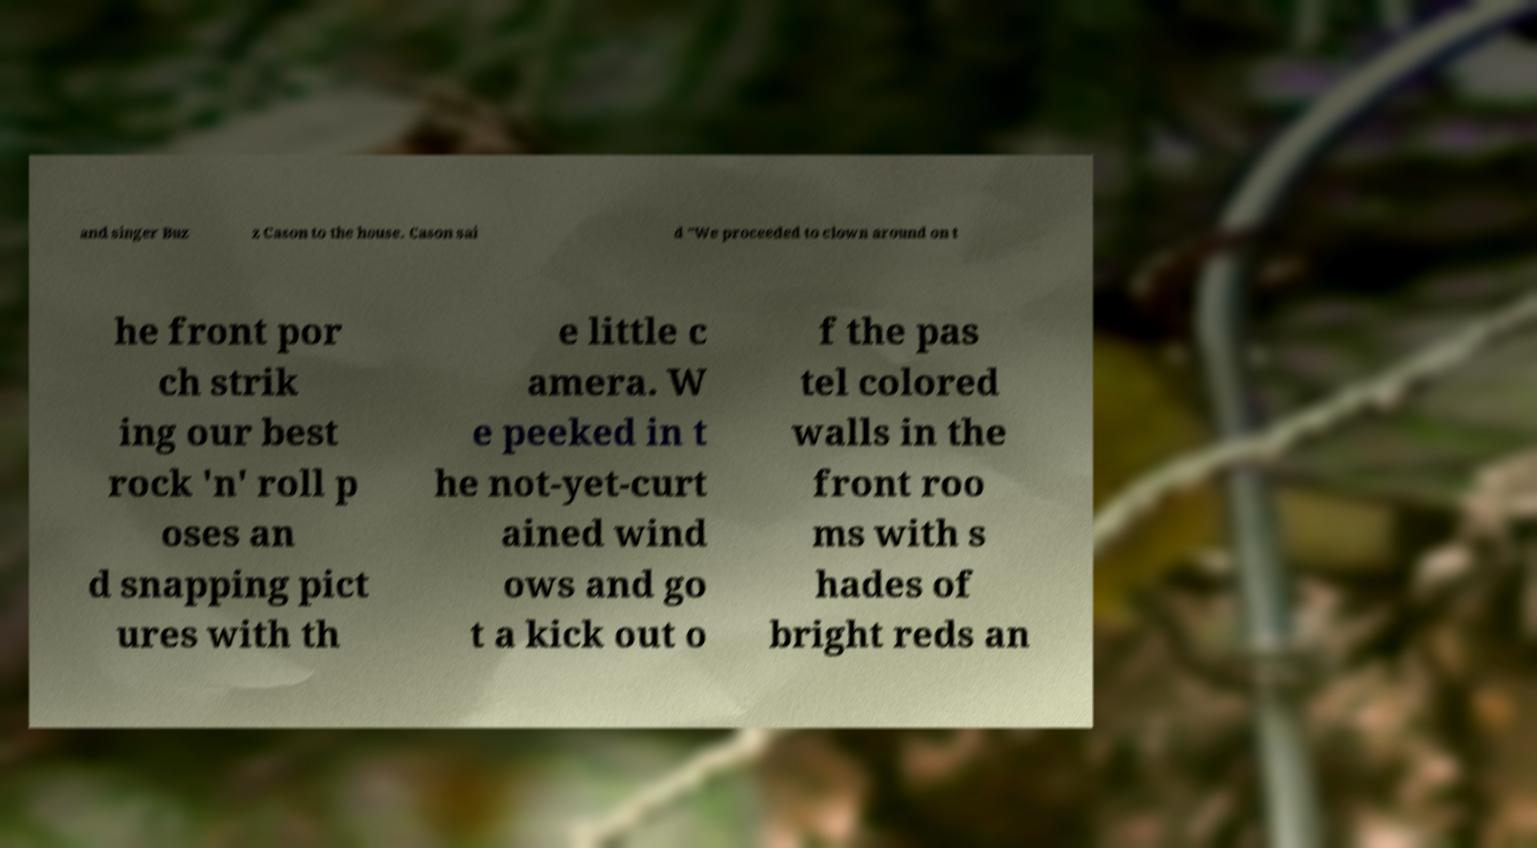Could you assist in decoding the text presented in this image and type it out clearly? and singer Buz z Cason to the house. Cason sai d "We proceeded to clown around on t he front por ch strik ing our best rock 'n' roll p oses an d snapping pict ures with th e little c amera. W e peeked in t he not-yet-curt ained wind ows and go t a kick out o f the pas tel colored walls in the front roo ms with s hades of bright reds an 